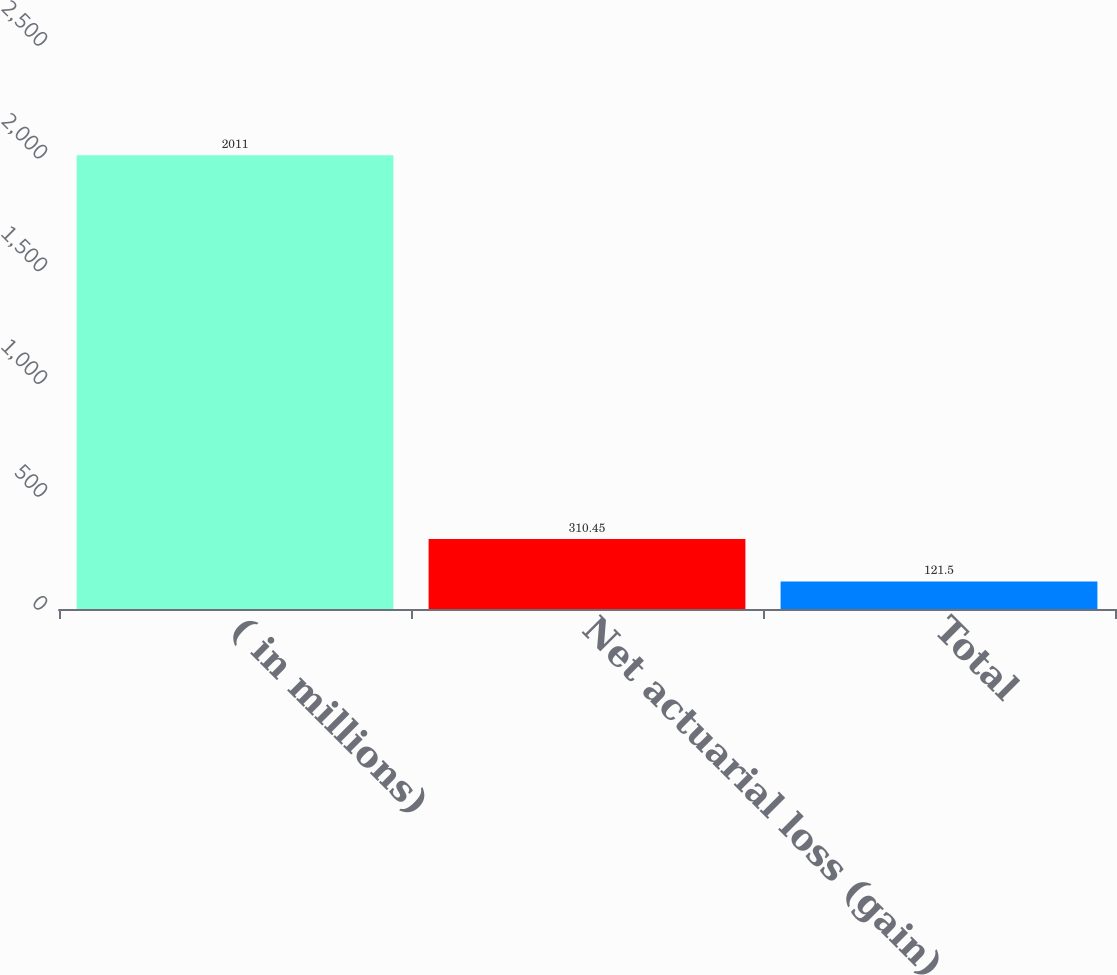Convert chart. <chart><loc_0><loc_0><loc_500><loc_500><bar_chart><fcel>( in millions)<fcel>Net actuarial loss (gain)<fcel>Total<nl><fcel>2011<fcel>310.45<fcel>121.5<nl></chart> 